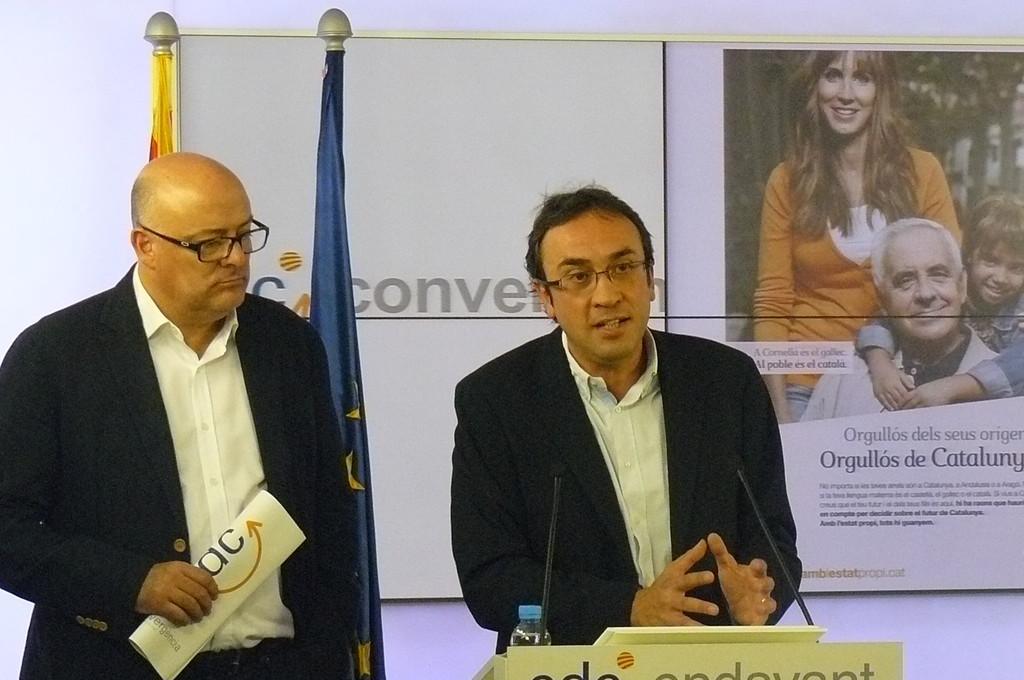How would you summarize this image in a sentence or two? In the picture I can see two people, among them one person is holding book, another person is talking in front of micro phone, bottle which is placed on the table and behind there are two flags, some banner's to the board which is attached to the wall. 